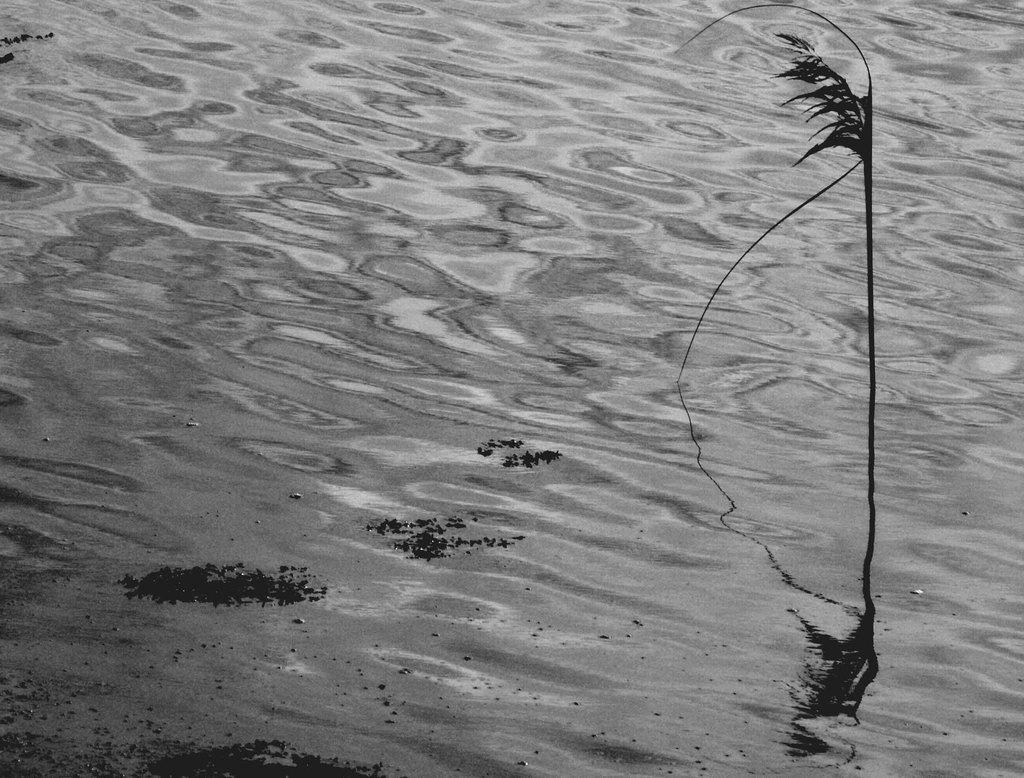What is the plant doing in the image? The plant is in the water. Can you describe the plant's environment in the image? The plant is submerged in water. What type of wine is being poured into the water in the image? There is no wine present in the image; it only features a plant in the water. 